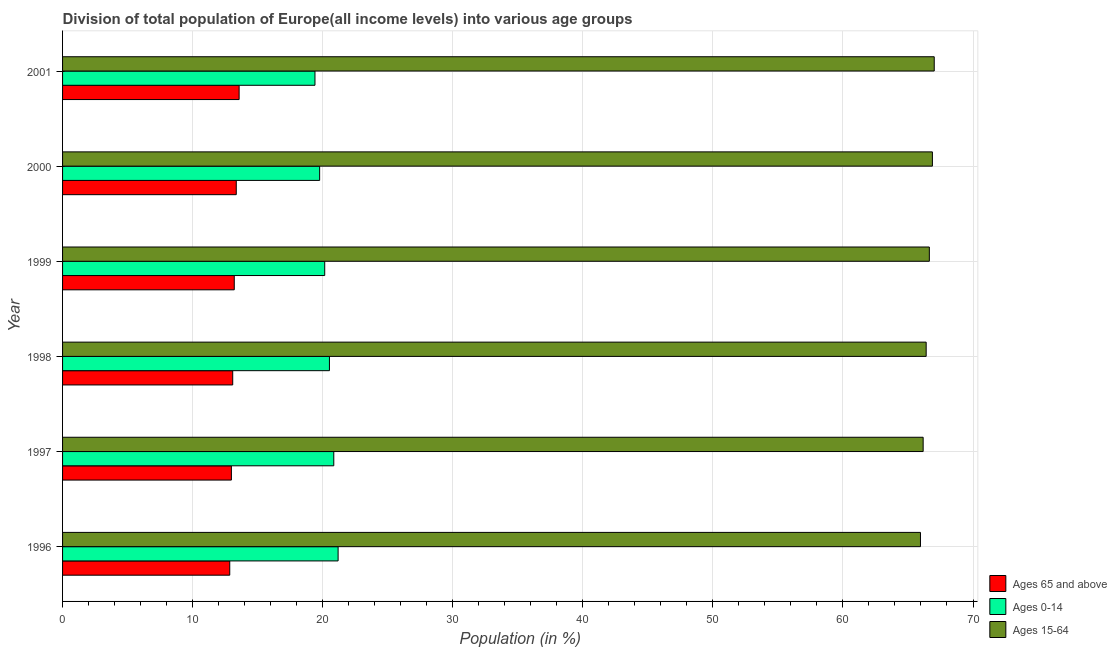How many groups of bars are there?
Your response must be concise. 6. Are the number of bars on each tick of the Y-axis equal?
Ensure brevity in your answer.  Yes. How many bars are there on the 6th tick from the top?
Your answer should be compact. 3. How many bars are there on the 3rd tick from the bottom?
Keep it short and to the point. 3. What is the label of the 2nd group of bars from the top?
Keep it short and to the point. 2000. In how many cases, is the number of bars for a given year not equal to the number of legend labels?
Keep it short and to the point. 0. What is the percentage of population within the age-group 0-14 in 1997?
Offer a very short reply. 20.85. Across all years, what is the maximum percentage of population within the age-group 0-14?
Provide a short and direct response. 21.18. Across all years, what is the minimum percentage of population within the age-group of 65 and above?
Your response must be concise. 12.85. In which year was the percentage of population within the age-group 0-14 maximum?
Give a very brief answer. 1996. What is the total percentage of population within the age-group 15-64 in the graph?
Make the answer very short. 399.07. What is the difference between the percentage of population within the age-group of 65 and above in 2000 and that in 2001?
Offer a terse response. -0.22. What is the difference between the percentage of population within the age-group 15-64 in 2000 and the percentage of population within the age-group of 65 and above in 1999?
Ensure brevity in your answer.  53.68. What is the average percentage of population within the age-group of 65 and above per year?
Provide a succinct answer. 13.18. In the year 2001, what is the difference between the percentage of population within the age-group 15-64 and percentage of population within the age-group of 65 and above?
Offer a terse response. 53.44. What is the ratio of the percentage of population within the age-group 15-64 in 1997 to that in 1999?
Provide a short and direct response. 0.99. Is the percentage of population within the age-group 0-14 in 1999 less than that in 2000?
Ensure brevity in your answer.  No. Is the difference between the percentage of population within the age-group of 65 and above in 1999 and 2000 greater than the difference between the percentage of population within the age-group 0-14 in 1999 and 2000?
Make the answer very short. No. What is the difference between the highest and the second highest percentage of population within the age-group of 65 and above?
Offer a very short reply. 0.22. What is the difference between the highest and the lowest percentage of population within the age-group 15-64?
Your answer should be compact. 1.06. Is the sum of the percentage of population within the age-group of 65 and above in 1997 and 2001 greater than the maximum percentage of population within the age-group 0-14 across all years?
Offer a terse response. Yes. What does the 3rd bar from the top in 1996 represents?
Your response must be concise. Ages 65 and above. What does the 3rd bar from the bottom in 1997 represents?
Ensure brevity in your answer.  Ages 15-64. What is the difference between two consecutive major ticks on the X-axis?
Ensure brevity in your answer.  10. Where does the legend appear in the graph?
Your answer should be very brief. Bottom right. What is the title of the graph?
Provide a succinct answer. Division of total population of Europe(all income levels) into various age groups
. What is the label or title of the X-axis?
Make the answer very short. Population (in %). What is the label or title of the Y-axis?
Keep it short and to the point. Year. What is the Population (in %) of Ages 65 and above in 1996?
Your response must be concise. 12.85. What is the Population (in %) of Ages 0-14 in 1996?
Provide a short and direct response. 21.18. What is the Population (in %) in Ages 15-64 in 1996?
Make the answer very short. 65.96. What is the Population (in %) of Ages 65 and above in 1997?
Offer a terse response. 12.98. What is the Population (in %) in Ages 0-14 in 1997?
Offer a terse response. 20.85. What is the Population (in %) in Ages 15-64 in 1997?
Give a very brief answer. 66.17. What is the Population (in %) of Ages 65 and above in 1998?
Provide a short and direct response. 13.08. What is the Population (in %) in Ages 0-14 in 1998?
Your answer should be very brief. 20.52. What is the Population (in %) of Ages 15-64 in 1998?
Your response must be concise. 66.4. What is the Population (in %) of Ages 65 and above in 1999?
Make the answer very short. 13.2. What is the Population (in %) in Ages 0-14 in 1999?
Ensure brevity in your answer.  20.16. What is the Population (in %) of Ages 15-64 in 1999?
Your response must be concise. 66.64. What is the Population (in %) of Ages 65 and above in 2000?
Provide a short and direct response. 13.36. What is the Population (in %) of Ages 0-14 in 2000?
Keep it short and to the point. 19.77. What is the Population (in %) in Ages 15-64 in 2000?
Your response must be concise. 66.88. What is the Population (in %) in Ages 65 and above in 2001?
Ensure brevity in your answer.  13.57. What is the Population (in %) in Ages 0-14 in 2001?
Offer a terse response. 19.41. What is the Population (in %) of Ages 15-64 in 2001?
Your answer should be very brief. 67.02. Across all years, what is the maximum Population (in %) of Ages 65 and above?
Provide a short and direct response. 13.57. Across all years, what is the maximum Population (in %) in Ages 0-14?
Provide a short and direct response. 21.18. Across all years, what is the maximum Population (in %) of Ages 15-64?
Provide a short and direct response. 67.02. Across all years, what is the minimum Population (in %) of Ages 65 and above?
Your answer should be very brief. 12.85. Across all years, what is the minimum Population (in %) in Ages 0-14?
Your response must be concise. 19.41. Across all years, what is the minimum Population (in %) of Ages 15-64?
Provide a short and direct response. 65.96. What is the total Population (in %) of Ages 65 and above in the graph?
Offer a terse response. 79.05. What is the total Population (in %) of Ages 0-14 in the graph?
Keep it short and to the point. 121.88. What is the total Population (in %) of Ages 15-64 in the graph?
Offer a very short reply. 399.07. What is the difference between the Population (in %) in Ages 65 and above in 1996 and that in 1997?
Provide a short and direct response. -0.13. What is the difference between the Population (in %) of Ages 0-14 in 1996 and that in 1997?
Provide a succinct answer. 0.33. What is the difference between the Population (in %) in Ages 15-64 in 1996 and that in 1997?
Offer a very short reply. -0.21. What is the difference between the Population (in %) in Ages 65 and above in 1996 and that in 1998?
Ensure brevity in your answer.  -0.23. What is the difference between the Population (in %) of Ages 0-14 in 1996 and that in 1998?
Provide a succinct answer. 0.67. What is the difference between the Population (in %) of Ages 15-64 in 1996 and that in 1998?
Give a very brief answer. -0.44. What is the difference between the Population (in %) of Ages 65 and above in 1996 and that in 1999?
Your answer should be very brief. -0.35. What is the difference between the Population (in %) in Ages 0-14 in 1996 and that in 1999?
Keep it short and to the point. 1.03. What is the difference between the Population (in %) of Ages 15-64 in 1996 and that in 1999?
Give a very brief answer. -0.68. What is the difference between the Population (in %) in Ages 65 and above in 1996 and that in 2000?
Offer a very short reply. -0.5. What is the difference between the Population (in %) of Ages 0-14 in 1996 and that in 2000?
Your answer should be compact. 1.42. What is the difference between the Population (in %) of Ages 15-64 in 1996 and that in 2000?
Give a very brief answer. -0.92. What is the difference between the Population (in %) of Ages 65 and above in 1996 and that in 2001?
Offer a very short reply. -0.72. What is the difference between the Population (in %) of Ages 0-14 in 1996 and that in 2001?
Offer a terse response. 1.78. What is the difference between the Population (in %) in Ages 15-64 in 1996 and that in 2001?
Ensure brevity in your answer.  -1.06. What is the difference between the Population (in %) in Ages 65 and above in 1997 and that in 1998?
Offer a terse response. -0.1. What is the difference between the Population (in %) of Ages 0-14 in 1997 and that in 1998?
Provide a succinct answer. 0.33. What is the difference between the Population (in %) in Ages 15-64 in 1997 and that in 1998?
Give a very brief answer. -0.23. What is the difference between the Population (in %) of Ages 65 and above in 1997 and that in 1999?
Give a very brief answer. -0.22. What is the difference between the Population (in %) in Ages 0-14 in 1997 and that in 1999?
Your answer should be compact. 0.7. What is the difference between the Population (in %) of Ages 15-64 in 1997 and that in 1999?
Provide a succinct answer. -0.48. What is the difference between the Population (in %) of Ages 65 and above in 1997 and that in 2000?
Provide a succinct answer. -0.38. What is the difference between the Population (in %) in Ages 0-14 in 1997 and that in 2000?
Keep it short and to the point. 1.09. What is the difference between the Population (in %) of Ages 15-64 in 1997 and that in 2000?
Make the answer very short. -0.71. What is the difference between the Population (in %) in Ages 65 and above in 1997 and that in 2001?
Your response must be concise. -0.59. What is the difference between the Population (in %) of Ages 0-14 in 1997 and that in 2001?
Provide a short and direct response. 1.45. What is the difference between the Population (in %) in Ages 15-64 in 1997 and that in 2001?
Provide a succinct answer. -0.85. What is the difference between the Population (in %) of Ages 65 and above in 1998 and that in 1999?
Offer a very short reply. -0.12. What is the difference between the Population (in %) in Ages 0-14 in 1998 and that in 1999?
Your response must be concise. 0.36. What is the difference between the Population (in %) in Ages 15-64 in 1998 and that in 1999?
Offer a terse response. -0.24. What is the difference between the Population (in %) of Ages 65 and above in 1998 and that in 2000?
Your answer should be compact. -0.27. What is the difference between the Population (in %) in Ages 0-14 in 1998 and that in 2000?
Offer a terse response. 0.75. What is the difference between the Population (in %) in Ages 15-64 in 1998 and that in 2000?
Keep it short and to the point. -0.48. What is the difference between the Population (in %) in Ages 65 and above in 1998 and that in 2001?
Offer a very short reply. -0.49. What is the difference between the Population (in %) in Ages 0-14 in 1998 and that in 2001?
Offer a very short reply. 1.11. What is the difference between the Population (in %) of Ages 15-64 in 1998 and that in 2001?
Your answer should be compact. -0.62. What is the difference between the Population (in %) of Ages 65 and above in 1999 and that in 2000?
Give a very brief answer. -0.15. What is the difference between the Population (in %) in Ages 0-14 in 1999 and that in 2000?
Provide a succinct answer. 0.39. What is the difference between the Population (in %) in Ages 15-64 in 1999 and that in 2000?
Your answer should be compact. -0.24. What is the difference between the Population (in %) in Ages 65 and above in 1999 and that in 2001?
Your response must be concise. -0.37. What is the difference between the Population (in %) in Ages 0-14 in 1999 and that in 2001?
Keep it short and to the point. 0.75. What is the difference between the Population (in %) in Ages 15-64 in 1999 and that in 2001?
Offer a very short reply. -0.38. What is the difference between the Population (in %) of Ages 65 and above in 2000 and that in 2001?
Give a very brief answer. -0.22. What is the difference between the Population (in %) of Ages 0-14 in 2000 and that in 2001?
Keep it short and to the point. 0.36. What is the difference between the Population (in %) in Ages 15-64 in 2000 and that in 2001?
Make the answer very short. -0.14. What is the difference between the Population (in %) in Ages 65 and above in 1996 and the Population (in %) in Ages 0-14 in 1997?
Provide a succinct answer. -8. What is the difference between the Population (in %) in Ages 65 and above in 1996 and the Population (in %) in Ages 15-64 in 1997?
Offer a very short reply. -53.31. What is the difference between the Population (in %) in Ages 0-14 in 1996 and the Population (in %) in Ages 15-64 in 1997?
Your response must be concise. -44.98. What is the difference between the Population (in %) of Ages 65 and above in 1996 and the Population (in %) of Ages 0-14 in 1998?
Ensure brevity in your answer.  -7.67. What is the difference between the Population (in %) of Ages 65 and above in 1996 and the Population (in %) of Ages 15-64 in 1998?
Give a very brief answer. -53.55. What is the difference between the Population (in %) of Ages 0-14 in 1996 and the Population (in %) of Ages 15-64 in 1998?
Make the answer very short. -45.21. What is the difference between the Population (in %) in Ages 65 and above in 1996 and the Population (in %) in Ages 0-14 in 1999?
Provide a short and direct response. -7.3. What is the difference between the Population (in %) of Ages 65 and above in 1996 and the Population (in %) of Ages 15-64 in 1999?
Your answer should be very brief. -53.79. What is the difference between the Population (in %) in Ages 0-14 in 1996 and the Population (in %) in Ages 15-64 in 1999?
Ensure brevity in your answer.  -45.46. What is the difference between the Population (in %) of Ages 65 and above in 1996 and the Population (in %) of Ages 0-14 in 2000?
Offer a terse response. -6.91. What is the difference between the Population (in %) of Ages 65 and above in 1996 and the Population (in %) of Ages 15-64 in 2000?
Provide a succinct answer. -54.02. What is the difference between the Population (in %) in Ages 0-14 in 1996 and the Population (in %) in Ages 15-64 in 2000?
Give a very brief answer. -45.69. What is the difference between the Population (in %) in Ages 65 and above in 1996 and the Population (in %) in Ages 0-14 in 2001?
Ensure brevity in your answer.  -6.55. What is the difference between the Population (in %) in Ages 65 and above in 1996 and the Population (in %) in Ages 15-64 in 2001?
Make the answer very short. -54.17. What is the difference between the Population (in %) in Ages 0-14 in 1996 and the Population (in %) in Ages 15-64 in 2001?
Keep it short and to the point. -45.83. What is the difference between the Population (in %) in Ages 65 and above in 1997 and the Population (in %) in Ages 0-14 in 1998?
Keep it short and to the point. -7.54. What is the difference between the Population (in %) of Ages 65 and above in 1997 and the Population (in %) of Ages 15-64 in 1998?
Give a very brief answer. -53.42. What is the difference between the Population (in %) of Ages 0-14 in 1997 and the Population (in %) of Ages 15-64 in 1998?
Provide a short and direct response. -45.55. What is the difference between the Population (in %) of Ages 65 and above in 1997 and the Population (in %) of Ages 0-14 in 1999?
Offer a very short reply. -7.18. What is the difference between the Population (in %) of Ages 65 and above in 1997 and the Population (in %) of Ages 15-64 in 1999?
Provide a short and direct response. -53.66. What is the difference between the Population (in %) of Ages 0-14 in 1997 and the Population (in %) of Ages 15-64 in 1999?
Your answer should be compact. -45.79. What is the difference between the Population (in %) of Ages 65 and above in 1997 and the Population (in %) of Ages 0-14 in 2000?
Keep it short and to the point. -6.79. What is the difference between the Population (in %) of Ages 65 and above in 1997 and the Population (in %) of Ages 15-64 in 2000?
Offer a very short reply. -53.9. What is the difference between the Population (in %) of Ages 0-14 in 1997 and the Population (in %) of Ages 15-64 in 2000?
Your answer should be very brief. -46.03. What is the difference between the Population (in %) in Ages 65 and above in 1997 and the Population (in %) in Ages 0-14 in 2001?
Make the answer very short. -6.43. What is the difference between the Population (in %) in Ages 65 and above in 1997 and the Population (in %) in Ages 15-64 in 2001?
Provide a short and direct response. -54.04. What is the difference between the Population (in %) in Ages 0-14 in 1997 and the Population (in %) in Ages 15-64 in 2001?
Offer a very short reply. -46.17. What is the difference between the Population (in %) of Ages 65 and above in 1998 and the Population (in %) of Ages 0-14 in 1999?
Your answer should be very brief. -7.07. What is the difference between the Population (in %) in Ages 65 and above in 1998 and the Population (in %) in Ages 15-64 in 1999?
Provide a short and direct response. -53.56. What is the difference between the Population (in %) in Ages 0-14 in 1998 and the Population (in %) in Ages 15-64 in 1999?
Provide a short and direct response. -46.12. What is the difference between the Population (in %) of Ages 65 and above in 1998 and the Population (in %) of Ages 0-14 in 2000?
Offer a terse response. -6.68. What is the difference between the Population (in %) in Ages 65 and above in 1998 and the Population (in %) in Ages 15-64 in 2000?
Make the answer very short. -53.8. What is the difference between the Population (in %) of Ages 0-14 in 1998 and the Population (in %) of Ages 15-64 in 2000?
Provide a short and direct response. -46.36. What is the difference between the Population (in %) of Ages 65 and above in 1998 and the Population (in %) of Ages 0-14 in 2001?
Your answer should be very brief. -6.32. What is the difference between the Population (in %) in Ages 65 and above in 1998 and the Population (in %) in Ages 15-64 in 2001?
Keep it short and to the point. -53.94. What is the difference between the Population (in %) of Ages 0-14 in 1998 and the Population (in %) of Ages 15-64 in 2001?
Keep it short and to the point. -46.5. What is the difference between the Population (in %) of Ages 65 and above in 1999 and the Population (in %) of Ages 0-14 in 2000?
Keep it short and to the point. -6.56. What is the difference between the Population (in %) of Ages 65 and above in 1999 and the Population (in %) of Ages 15-64 in 2000?
Your response must be concise. -53.68. What is the difference between the Population (in %) of Ages 0-14 in 1999 and the Population (in %) of Ages 15-64 in 2000?
Your answer should be very brief. -46.72. What is the difference between the Population (in %) of Ages 65 and above in 1999 and the Population (in %) of Ages 0-14 in 2001?
Provide a succinct answer. -6.2. What is the difference between the Population (in %) of Ages 65 and above in 1999 and the Population (in %) of Ages 15-64 in 2001?
Your response must be concise. -53.82. What is the difference between the Population (in %) of Ages 0-14 in 1999 and the Population (in %) of Ages 15-64 in 2001?
Offer a terse response. -46.86. What is the difference between the Population (in %) in Ages 65 and above in 2000 and the Population (in %) in Ages 0-14 in 2001?
Ensure brevity in your answer.  -6.05. What is the difference between the Population (in %) in Ages 65 and above in 2000 and the Population (in %) in Ages 15-64 in 2001?
Your answer should be compact. -53.66. What is the difference between the Population (in %) in Ages 0-14 in 2000 and the Population (in %) in Ages 15-64 in 2001?
Your answer should be very brief. -47.25. What is the average Population (in %) in Ages 65 and above per year?
Offer a very short reply. 13.17. What is the average Population (in %) of Ages 0-14 per year?
Make the answer very short. 20.31. What is the average Population (in %) in Ages 15-64 per year?
Your answer should be compact. 66.51. In the year 1996, what is the difference between the Population (in %) in Ages 65 and above and Population (in %) in Ages 0-14?
Keep it short and to the point. -8.33. In the year 1996, what is the difference between the Population (in %) in Ages 65 and above and Population (in %) in Ages 15-64?
Give a very brief answer. -53.11. In the year 1996, what is the difference between the Population (in %) of Ages 0-14 and Population (in %) of Ages 15-64?
Provide a short and direct response. -44.78. In the year 1997, what is the difference between the Population (in %) of Ages 65 and above and Population (in %) of Ages 0-14?
Provide a short and direct response. -7.87. In the year 1997, what is the difference between the Population (in %) in Ages 65 and above and Population (in %) in Ages 15-64?
Make the answer very short. -53.19. In the year 1997, what is the difference between the Population (in %) of Ages 0-14 and Population (in %) of Ages 15-64?
Give a very brief answer. -45.31. In the year 1998, what is the difference between the Population (in %) in Ages 65 and above and Population (in %) in Ages 0-14?
Make the answer very short. -7.44. In the year 1998, what is the difference between the Population (in %) in Ages 65 and above and Population (in %) in Ages 15-64?
Offer a very short reply. -53.32. In the year 1998, what is the difference between the Population (in %) in Ages 0-14 and Population (in %) in Ages 15-64?
Give a very brief answer. -45.88. In the year 1999, what is the difference between the Population (in %) in Ages 65 and above and Population (in %) in Ages 0-14?
Offer a very short reply. -6.95. In the year 1999, what is the difference between the Population (in %) in Ages 65 and above and Population (in %) in Ages 15-64?
Offer a terse response. -53.44. In the year 1999, what is the difference between the Population (in %) in Ages 0-14 and Population (in %) in Ages 15-64?
Your answer should be compact. -46.49. In the year 2000, what is the difference between the Population (in %) in Ages 65 and above and Population (in %) in Ages 0-14?
Provide a short and direct response. -6.41. In the year 2000, what is the difference between the Population (in %) in Ages 65 and above and Population (in %) in Ages 15-64?
Give a very brief answer. -53.52. In the year 2000, what is the difference between the Population (in %) of Ages 0-14 and Population (in %) of Ages 15-64?
Your answer should be compact. -47.11. In the year 2001, what is the difference between the Population (in %) in Ages 65 and above and Population (in %) in Ages 0-14?
Offer a very short reply. -5.83. In the year 2001, what is the difference between the Population (in %) of Ages 65 and above and Population (in %) of Ages 15-64?
Ensure brevity in your answer.  -53.44. In the year 2001, what is the difference between the Population (in %) in Ages 0-14 and Population (in %) in Ages 15-64?
Your answer should be very brief. -47.61. What is the ratio of the Population (in %) in Ages 65 and above in 1996 to that in 1997?
Ensure brevity in your answer.  0.99. What is the ratio of the Population (in %) of Ages 0-14 in 1996 to that in 1997?
Your answer should be compact. 1.02. What is the ratio of the Population (in %) in Ages 15-64 in 1996 to that in 1997?
Offer a terse response. 1. What is the ratio of the Population (in %) in Ages 65 and above in 1996 to that in 1998?
Keep it short and to the point. 0.98. What is the ratio of the Population (in %) of Ages 0-14 in 1996 to that in 1998?
Offer a terse response. 1.03. What is the ratio of the Population (in %) in Ages 15-64 in 1996 to that in 1998?
Keep it short and to the point. 0.99. What is the ratio of the Population (in %) of Ages 65 and above in 1996 to that in 1999?
Offer a terse response. 0.97. What is the ratio of the Population (in %) of Ages 0-14 in 1996 to that in 1999?
Make the answer very short. 1.05. What is the ratio of the Population (in %) of Ages 15-64 in 1996 to that in 1999?
Offer a terse response. 0.99. What is the ratio of the Population (in %) of Ages 65 and above in 1996 to that in 2000?
Ensure brevity in your answer.  0.96. What is the ratio of the Population (in %) of Ages 0-14 in 1996 to that in 2000?
Offer a very short reply. 1.07. What is the ratio of the Population (in %) of Ages 15-64 in 1996 to that in 2000?
Make the answer very short. 0.99. What is the ratio of the Population (in %) of Ages 65 and above in 1996 to that in 2001?
Offer a terse response. 0.95. What is the ratio of the Population (in %) of Ages 0-14 in 1996 to that in 2001?
Keep it short and to the point. 1.09. What is the ratio of the Population (in %) of Ages 15-64 in 1996 to that in 2001?
Make the answer very short. 0.98. What is the ratio of the Population (in %) in Ages 65 and above in 1997 to that in 1998?
Ensure brevity in your answer.  0.99. What is the ratio of the Population (in %) of Ages 0-14 in 1997 to that in 1998?
Provide a succinct answer. 1.02. What is the ratio of the Population (in %) in Ages 65 and above in 1997 to that in 1999?
Provide a short and direct response. 0.98. What is the ratio of the Population (in %) in Ages 0-14 in 1997 to that in 1999?
Your answer should be compact. 1.03. What is the ratio of the Population (in %) in Ages 65 and above in 1997 to that in 2000?
Provide a short and direct response. 0.97. What is the ratio of the Population (in %) in Ages 0-14 in 1997 to that in 2000?
Make the answer very short. 1.05. What is the ratio of the Population (in %) of Ages 65 and above in 1997 to that in 2001?
Your answer should be very brief. 0.96. What is the ratio of the Population (in %) in Ages 0-14 in 1997 to that in 2001?
Your answer should be compact. 1.07. What is the ratio of the Population (in %) in Ages 15-64 in 1997 to that in 2001?
Give a very brief answer. 0.99. What is the ratio of the Population (in %) of Ages 65 and above in 1998 to that in 1999?
Provide a short and direct response. 0.99. What is the ratio of the Population (in %) of Ages 0-14 in 1998 to that in 1999?
Offer a very short reply. 1.02. What is the ratio of the Population (in %) in Ages 65 and above in 1998 to that in 2000?
Offer a terse response. 0.98. What is the ratio of the Population (in %) of Ages 0-14 in 1998 to that in 2000?
Your response must be concise. 1.04. What is the ratio of the Population (in %) of Ages 65 and above in 1998 to that in 2001?
Ensure brevity in your answer.  0.96. What is the ratio of the Population (in %) of Ages 0-14 in 1998 to that in 2001?
Offer a terse response. 1.06. What is the ratio of the Population (in %) of Ages 65 and above in 1999 to that in 2000?
Provide a short and direct response. 0.99. What is the ratio of the Population (in %) of Ages 0-14 in 1999 to that in 2000?
Keep it short and to the point. 1.02. What is the ratio of the Population (in %) in Ages 15-64 in 1999 to that in 2000?
Your answer should be very brief. 1. What is the ratio of the Population (in %) in Ages 65 and above in 1999 to that in 2001?
Make the answer very short. 0.97. What is the ratio of the Population (in %) in Ages 0-14 in 1999 to that in 2001?
Your answer should be very brief. 1.04. What is the ratio of the Population (in %) in Ages 65 and above in 2000 to that in 2001?
Make the answer very short. 0.98. What is the ratio of the Population (in %) in Ages 0-14 in 2000 to that in 2001?
Ensure brevity in your answer.  1.02. What is the difference between the highest and the second highest Population (in %) in Ages 65 and above?
Provide a succinct answer. 0.22. What is the difference between the highest and the second highest Population (in %) of Ages 0-14?
Provide a succinct answer. 0.33. What is the difference between the highest and the second highest Population (in %) of Ages 15-64?
Provide a short and direct response. 0.14. What is the difference between the highest and the lowest Population (in %) of Ages 65 and above?
Keep it short and to the point. 0.72. What is the difference between the highest and the lowest Population (in %) in Ages 0-14?
Offer a very short reply. 1.78. What is the difference between the highest and the lowest Population (in %) in Ages 15-64?
Keep it short and to the point. 1.06. 